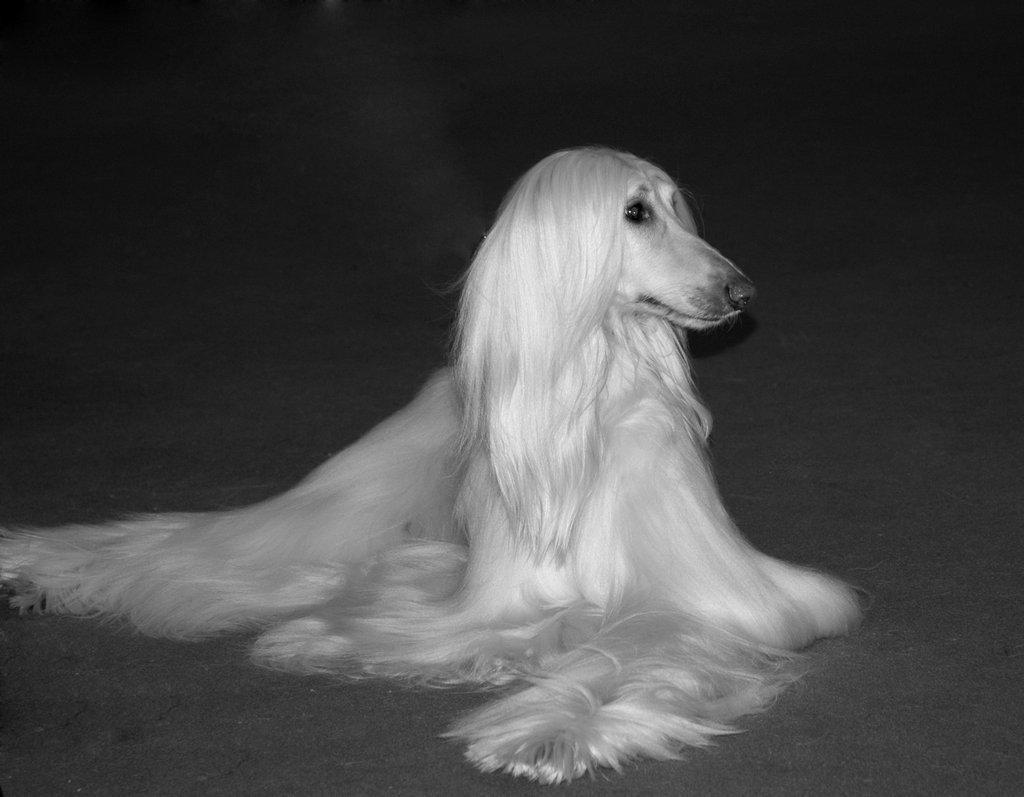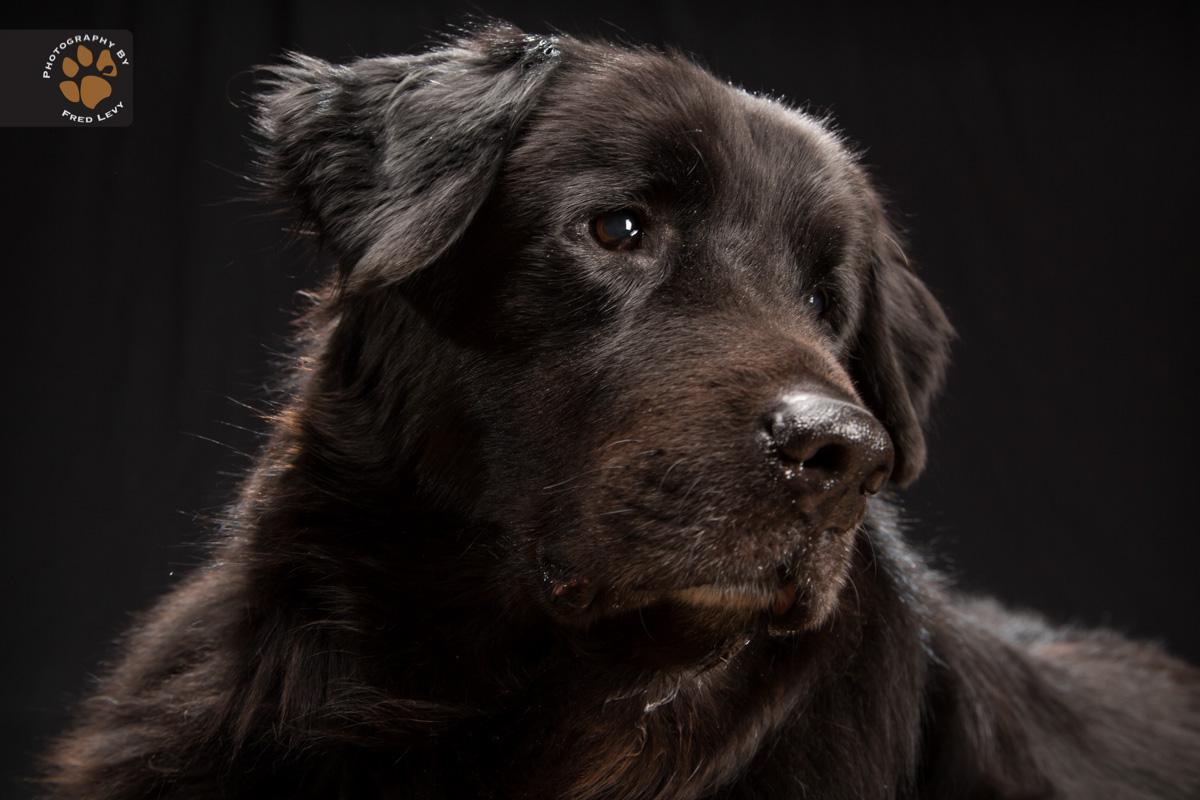The first image is the image on the left, the second image is the image on the right. Evaluate the accuracy of this statement regarding the images: "One of the images has a black dog with long hair standing up.". Is it true? Answer yes or no. No. The first image is the image on the left, the second image is the image on the right. Considering the images on both sides, is "Each image contains a black afghan hound, and the right image shows a hound standing with its body in profile." valid? Answer yes or no. No. 